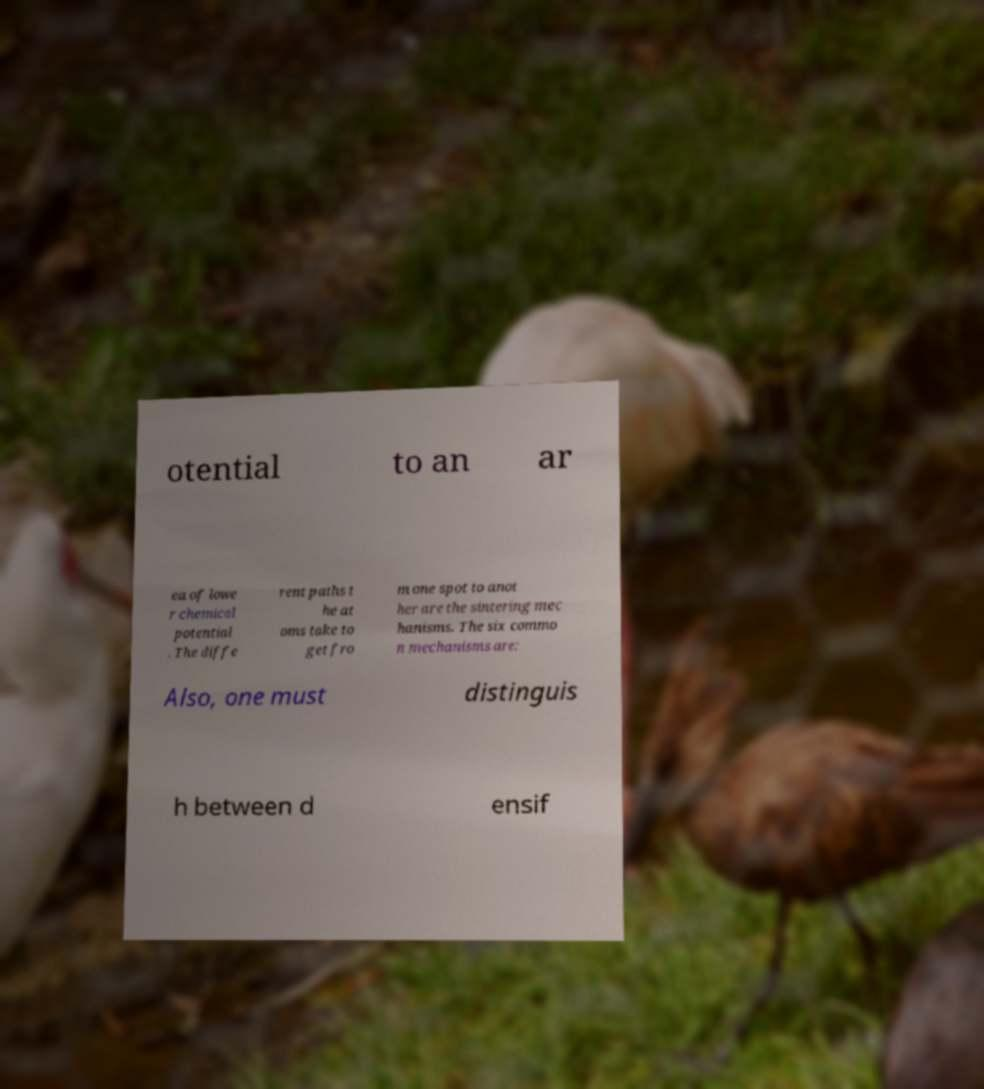Can you accurately transcribe the text from the provided image for me? otential to an ar ea of lowe r chemical potential . The diffe rent paths t he at oms take to get fro m one spot to anot her are the sintering mec hanisms. The six commo n mechanisms are: Also, one must distinguis h between d ensif 